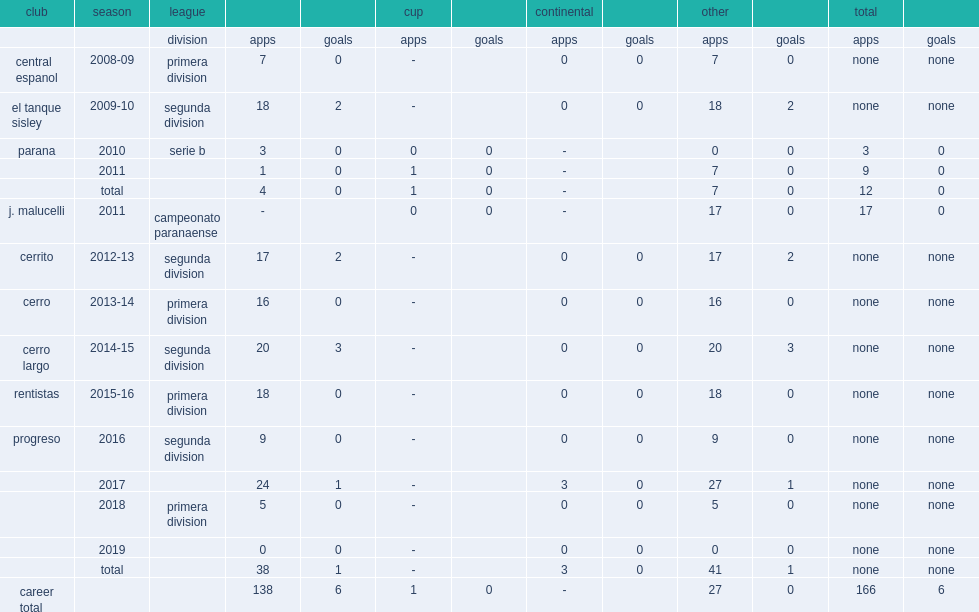Which club did mendez play for in 2013-14? Cerro. 